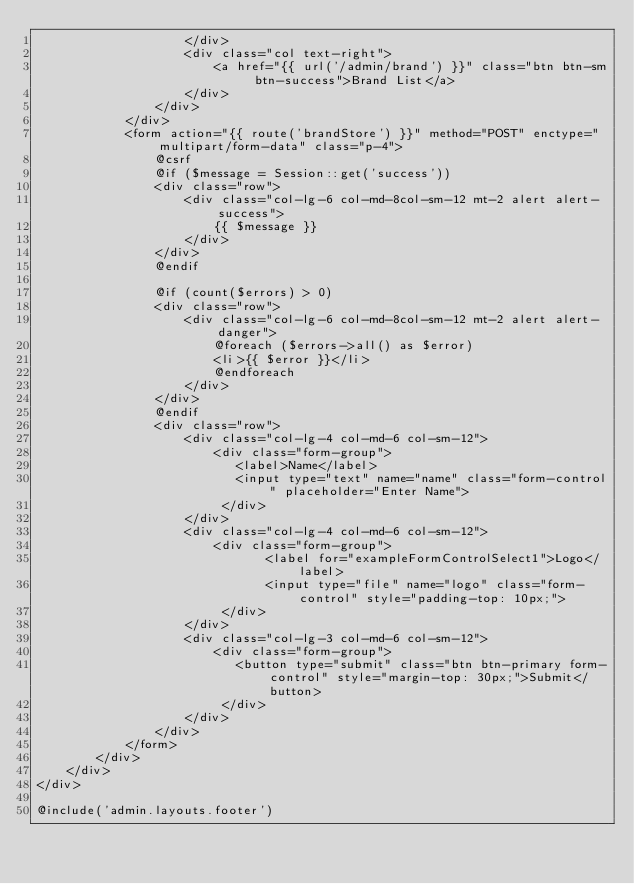<code> <loc_0><loc_0><loc_500><loc_500><_PHP_>					</div>
					<div class="col text-right">
						<a href="{{ url('/admin/brand') }}" class="btn btn-sm btn-success">Brand List</a>
					</div>
				</div>
			</div>
			<form action="{{ route('brandStore') }}" method="POST" enctype="multipart/form-data" class="p-4">
				@csrf
				@if ($message = Session::get('success'))
				<div class="row">
					<div class="col-lg-6 col-md-8col-sm-12 mt-2 alert alert-success">
						{{ $message }}
					</div>
				</div>
				@endif

				@if (count($errors) > 0)
				<div class="row">
					<div class="col-lg-6 col-md-8col-sm-12 mt-2 alert alert-danger">
						@foreach ($errors->all() as $error)
						<li>{{ $error }}</li>
						@endforeach
					</div>
				</div>
				@endif
				<div class="row">
					<div class="col-lg-4 col-md-6 col-sm-12">
						<div class="form-group">
						   <label>Name</label>
						   <input type="text" name="name" class="form-control" placeholder="Enter Name">
						 </div>
					</div>
					<div class="col-lg-4 col-md-6 col-sm-12">
						<div class="form-group">
							   <label for="exampleFormControlSelect1">Logo</label>
							   <input type="file" name="logo" class="form-control" style="padding-top: 10px;">
						 </div>
					</div>
					<div class="col-lg-3 col-md-6 col-sm-12">
						<div class="form-group">
						   <button type="submit" class="btn btn-primary form-control" style="margin-top: 30px;">Submit</button>
						 </div>
					</div>
				</div>
			</form>
		</div>
	</div>
</div>

@include('admin.layouts.footer')</code> 